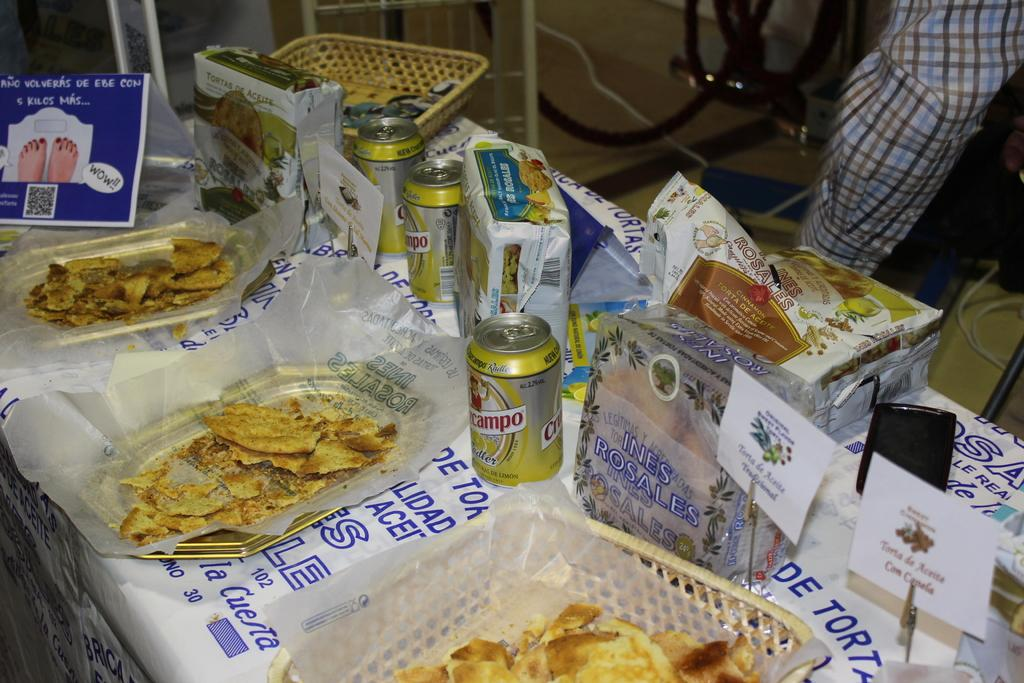What types of containers are visible in the image? There are tins and baskets in the image. What else can be seen in the image besides containers? There are food items, papers, a mobile, and unspecified objects in the image. What is the background of the image like? There is a cloth in the background of the image, and cables are visible on the floor. What type of baseball equipment can be seen in the image? There is no baseball equipment present in the image. What type of oven is visible in the image? There is no oven present in the image. 